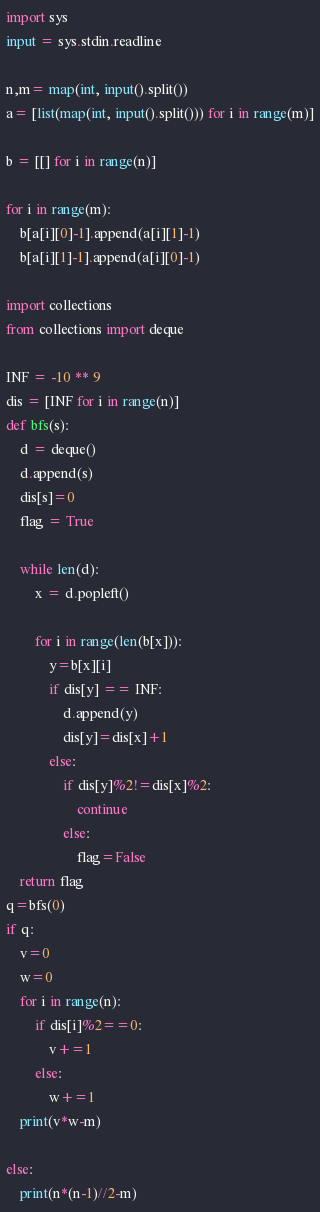<code> <loc_0><loc_0><loc_500><loc_500><_Python_>import sys
input = sys.stdin.readline

n,m= map(int, input().split())
a= [list(map(int, input().split())) for i in range(m)]

b = [[] for i in range(n)]

for i in range(m):
    b[a[i][0]-1].append(a[i][1]-1)
    b[a[i][1]-1].append(a[i][0]-1)

import collections
from collections import deque

INF = -10 ** 9
dis = [INF for i in range(n)]
def bfs(s):
    d = deque()
    d.append(s)
    dis[s]=0
    flag = True

    while len(d):
        x = d.popleft()

        for i in range(len(b[x])):
            y=b[x][i]
            if dis[y] == INF:
                d.append(y)
                dis[y]=dis[x]+1
            else:
                if dis[y]%2!=dis[x]%2:
                    continue
                else:
                    flag=False
    return flag
q=bfs(0)
if q:
    v=0
    w=0
    for i in range(n):
        if dis[i]%2==0:
            v+=1
        else:
            w+=1
    print(v*w-m)

else:
    print(n*(n-1)//2-m)</code> 